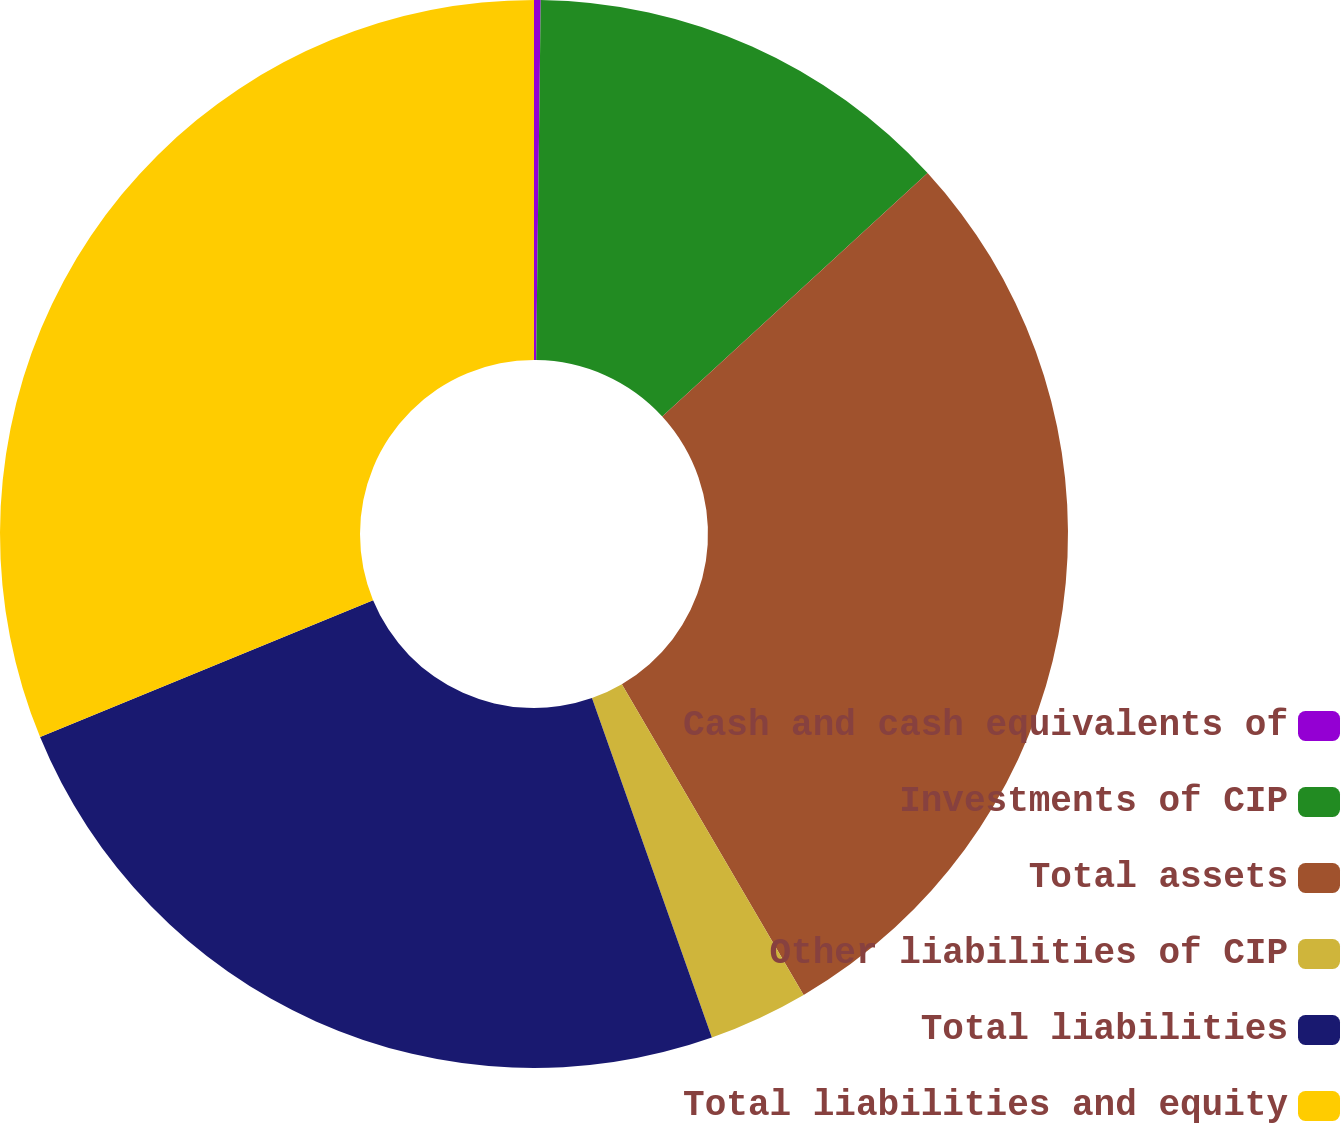Convert chart. <chart><loc_0><loc_0><loc_500><loc_500><pie_chart><fcel>Cash and cash equivalents of<fcel>Investments of CIP<fcel>Total assets<fcel>Other liabilities of CIP<fcel>Total liabilities<fcel>Total liabilities and equity<nl><fcel>0.2%<fcel>12.99%<fcel>28.39%<fcel>3.02%<fcel>24.2%<fcel>31.21%<nl></chart> 